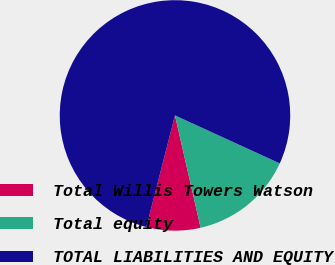Convert chart. <chart><loc_0><loc_0><loc_500><loc_500><pie_chart><fcel>Total Willis Towers Watson<fcel>Total equity<fcel>TOTAL LIABILITIES AND EQUITY<nl><fcel>7.57%<fcel>14.6%<fcel>77.84%<nl></chart> 